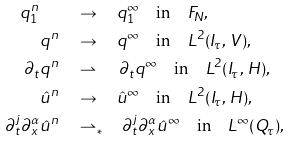<formula> <loc_0><loc_0><loc_500><loc_500>q ^ { n } _ { 1 } \quad & \to \quad q ^ { \infty } _ { 1 } \quad \text {in} \quad F _ { N } , \\ q ^ { n } \quad & \to \quad q ^ { \infty } \quad \text {in} \quad L ^ { 2 } ( I _ { \tau } , \, V ) , \\ \partial _ { t } q ^ { n } \quad & \rightharpoonup \quad \, \partial _ { t } q ^ { \infty } \quad \text {in} \quad L ^ { 2 } ( I _ { \tau } , \, H ) , \\ \hat { u } ^ { n } \quad & \to \quad \hat { u } ^ { \infty } \quad \text {in} \quad L ^ { 2 } ( I _ { \tau } , \, H ) , \\ \partial _ { t } ^ { j } \partial _ { x } ^ { \alpha } \hat { u } ^ { n } \quad & \rightharpoonup _ { \ast } \quad \partial _ { t } ^ { j } \partial _ { x } ^ { \alpha } \hat { u } ^ { \infty } \quad \text {in} \quad L ^ { \infty } ( Q _ { \tau } ) ,</formula> 